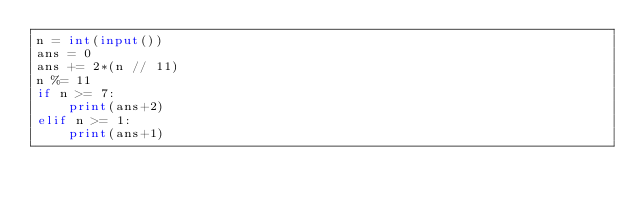<code> <loc_0><loc_0><loc_500><loc_500><_Python_>n = int(input())
ans = 0
ans += 2*(n // 11)
n %= 11
if n >= 7:
    print(ans+2)
elif n >= 1:
    print(ans+1)</code> 